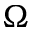<formula> <loc_0><loc_0><loc_500><loc_500>\Omega</formula> 